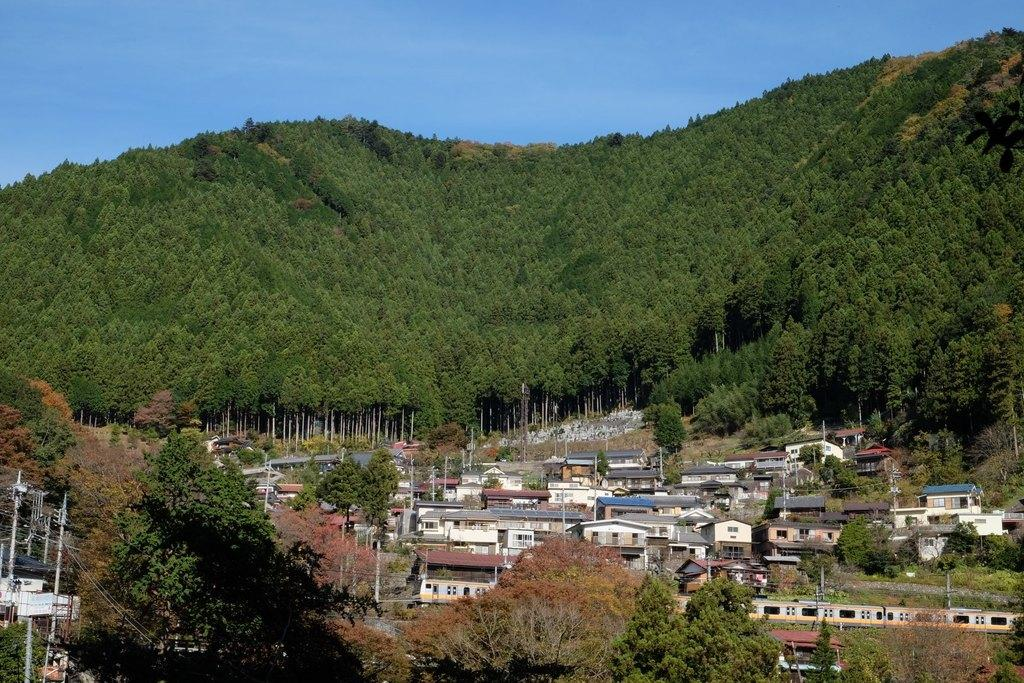What type of structures can be seen in the image? There are buildings in the image. What natural elements are present in the image? There are trees and hills in the image. What man-made objects can be seen in the image? There are poles and cables in the image. What part of the natural environment is visible in the image? The sky is visible in the background of the image. What advice does the grandfather give in the image? There is no grandfather or any advice given in the image. Can you see a plane flying in the sky in the image? There is no plane visible in the sky in the image. 